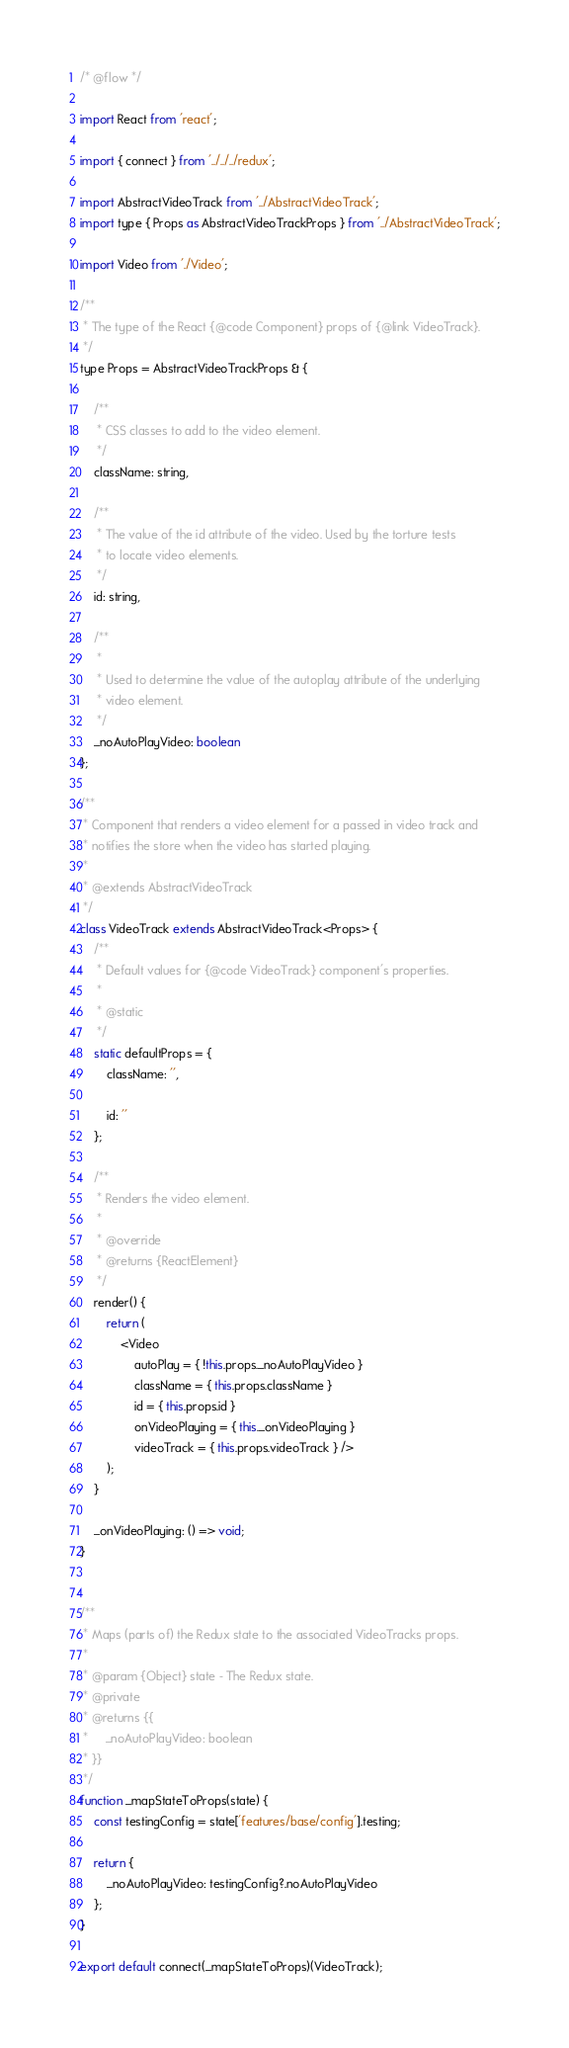<code> <loc_0><loc_0><loc_500><loc_500><_JavaScript_>/* @flow */

import React from 'react';

import { connect } from '../../../redux';

import AbstractVideoTrack from '../AbstractVideoTrack';
import type { Props as AbstractVideoTrackProps } from '../AbstractVideoTrack';

import Video from './Video';

/**
 * The type of the React {@code Component} props of {@link VideoTrack}.
 */
type Props = AbstractVideoTrackProps & {

    /**
     * CSS classes to add to the video element.
     */
    className: string,

    /**
     * The value of the id attribute of the video. Used by the torture tests
     * to locate video elements.
     */
    id: string,

    /**
     *
     * Used to determine the value of the autoplay attribute of the underlying
     * video element.
     */
    _noAutoPlayVideo: boolean
};

/**
 * Component that renders a video element for a passed in video track and
 * notifies the store when the video has started playing.
 *
 * @extends AbstractVideoTrack
 */
class VideoTrack extends AbstractVideoTrack<Props> {
    /**
     * Default values for {@code VideoTrack} component's properties.
     *
     * @static
     */
    static defaultProps = {
        className: '',

        id: ''
    };

    /**
     * Renders the video element.
     *
     * @override
     * @returns {ReactElement}
     */
    render() {
        return (
            <Video
                autoPlay = { !this.props._noAutoPlayVideo }
                className = { this.props.className }
                id = { this.props.id }
                onVideoPlaying = { this._onVideoPlaying }
                videoTrack = { this.props.videoTrack } />
        );
    }

    _onVideoPlaying: () => void;
}


/**
 * Maps (parts of) the Redux state to the associated VideoTracks props.
 *
 * @param {Object} state - The Redux state.
 * @private
 * @returns {{
 *     _noAutoPlayVideo: boolean
 * }}
 */
function _mapStateToProps(state) {
    const testingConfig = state['features/base/config'].testing;

    return {
        _noAutoPlayVideo: testingConfig?.noAutoPlayVideo
    };
}

export default connect(_mapStateToProps)(VideoTrack);
</code> 